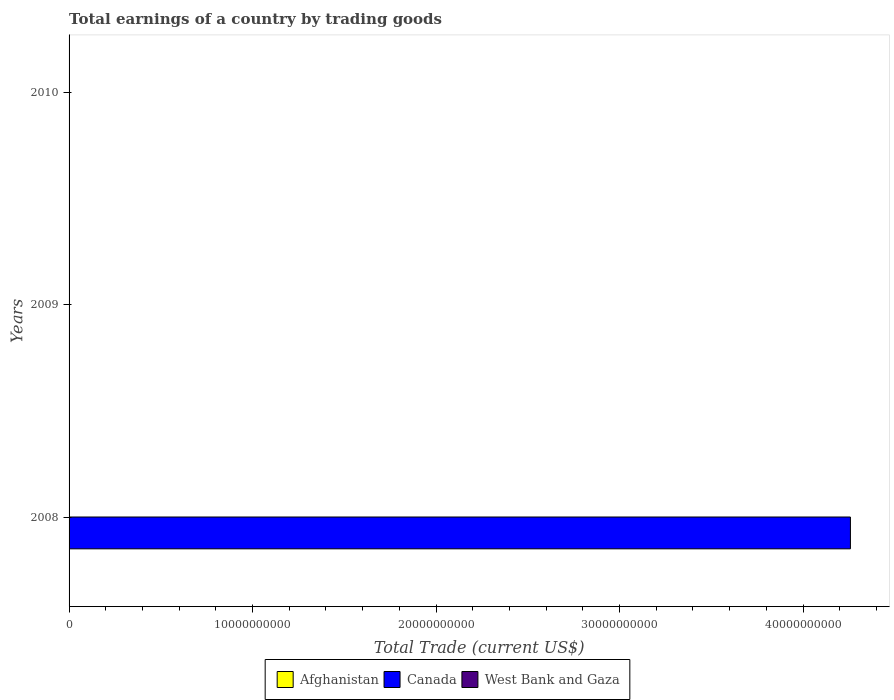How many different coloured bars are there?
Keep it short and to the point. 1. Are the number of bars per tick equal to the number of legend labels?
Provide a short and direct response. No. Are the number of bars on each tick of the Y-axis equal?
Keep it short and to the point. No. How many bars are there on the 1st tick from the top?
Give a very brief answer. 0. How many bars are there on the 2nd tick from the bottom?
Your answer should be very brief. 0. What is the label of the 3rd group of bars from the top?
Your response must be concise. 2008. What is the total earnings in West Bank and Gaza in 2010?
Make the answer very short. 0. Across all years, what is the maximum total earnings in Canada?
Offer a terse response. 4.26e+1. Across all years, what is the minimum total earnings in Canada?
Offer a very short reply. 0. In which year was the total earnings in Canada maximum?
Give a very brief answer. 2008. What is the total total earnings in Canada in the graph?
Your answer should be compact. 4.26e+1. What is the difference between the total earnings in Canada in 2010 and the total earnings in West Bank and Gaza in 2008?
Your answer should be very brief. 0. What is the difference between the highest and the lowest total earnings in Canada?
Your response must be concise. 4.26e+1. Are all the bars in the graph horizontal?
Give a very brief answer. Yes. What is the difference between two consecutive major ticks on the X-axis?
Offer a very short reply. 1.00e+1. Does the graph contain any zero values?
Provide a succinct answer. Yes. Does the graph contain grids?
Your answer should be compact. No. How many legend labels are there?
Give a very brief answer. 3. How are the legend labels stacked?
Your answer should be compact. Horizontal. What is the title of the graph?
Your answer should be compact. Total earnings of a country by trading goods. Does "Egypt, Arab Rep." appear as one of the legend labels in the graph?
Provide a short and direct response. No. What is the label or title of the X-axis?
Provide a succinct answer. Total Trade (current US$). What is the label or title of the Y-axis?
Provide a succinct answer. Years. What is the Total Trade (current US$) of Afghanistan in 2008?
Make the answer very short. 0. What is the Total Trade (current US$) in Canada in 2008?
Ensure brevity in your answer.  4.26e+1. What is the Total Trade (current US$) in West Bank and Gaza in 2008?
Offer a very short reply. 0. What is the Total Trade (current US$) of Afghanistan in 2009?
Provide a succinct answer. 0. What is the Total Trade (current US$) in Canada in 2009?
Offer a very short reply. 0. What is the Total Trade (current US$) of Afghanistan in 2010?
Your response must be concise. 0. Across all years, what is the maximum Total Trade (current US$) of Canada?
Provide a short and direct response. 4.26e+1. What is the total Total Trade (current US$) of Canada in the graph?
Provide a succinct answer. 4.26e+1. What is the average Total Trade (current US$) in Afghanistan per year?
Provide a succinct answer. 0. What is the average Total Trade (current US$) of Canada per year?
Your response must be concise. 1.42e+1. What is the difference between the highest and the lowest Total Trade (current US$) in Canada?
Your answer should be very brief. 4.26e+1. 